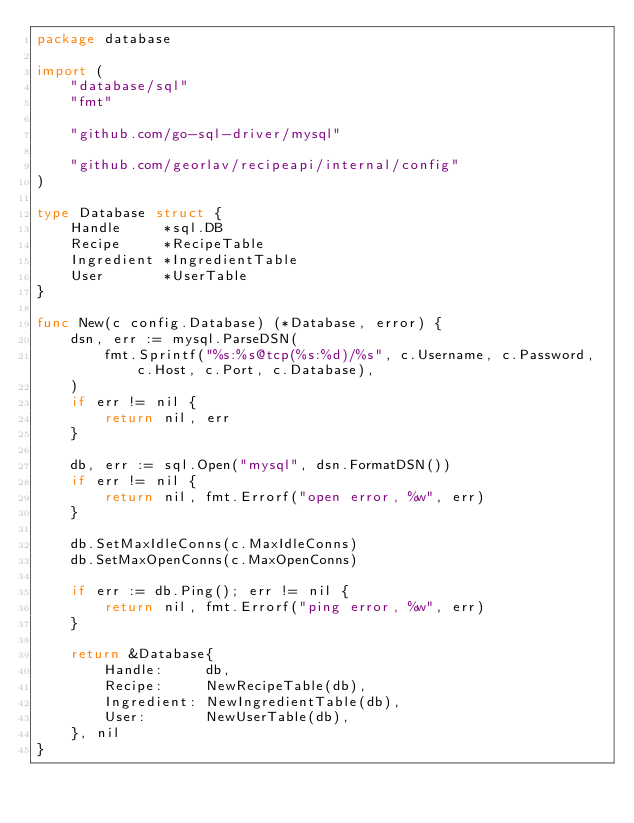Convert code to text. <code><loc_0><loc_0><loc_500><loc_500><_Go_>package database

import (
	"database/sql"
	"fmt"

	"github.com/go-sql-driver/mysql"

	"github.com/georlav/recipeapi/internal/config"
)

type Database struct {
	Handle     *sql.DB
	Recipe     *RecipeTable
	Ingredient *IngredientTable
	User       *UserTable
}

func New(c config.Database) (*Database, error) {
	dsn, err := mysql.ParseDSN(
		fmt.Sprintf("%s:%s@tcp(%s:%d)/%s", c.Username, c.Password, c.Host, c.Port, c.Database),
	)
	if err != nil {
		return nil, err
	}

	db, err := sql.Open("mysql", dsn.FormatDSN())
	if err != nil {
		return nil, fmt.Errorf("open error, %w", err)
	}

	db.SetMaxIdleConns(c.MaxIdleConns)
	db.SetMaxOpenConns(c.MaxOpenConns)

	if err := db.Ping(); err != nil {
		return nil, fmt.Errorf("ping error, %w", err)
	}

	return &Database{
		Handle:     db,
		Recipe:     NewRecipeTable(db),
		Ingredient: NewIngredientTable(db),
		User:       NewUserTable(db),
	}, nil
}
</code> 